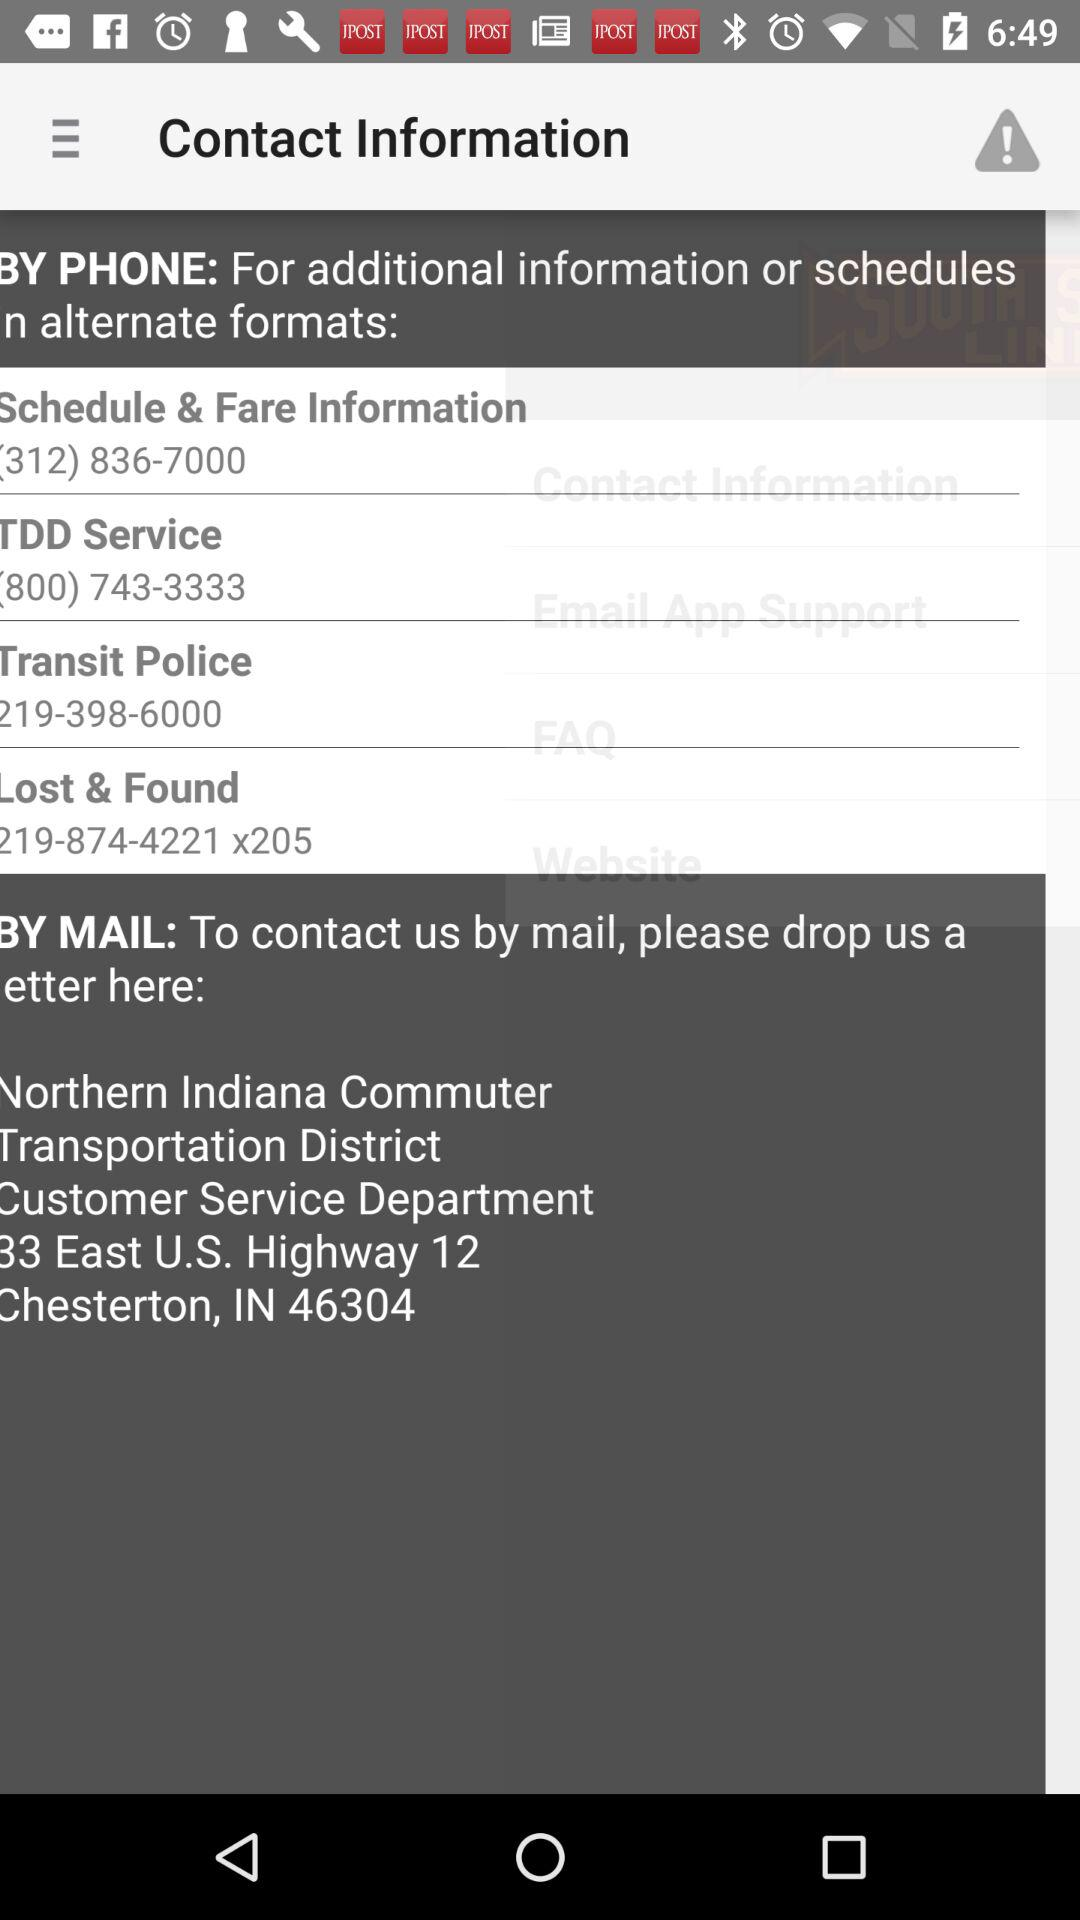What is the contact number for information about the transit police? The contact number is 219-398-6000. 